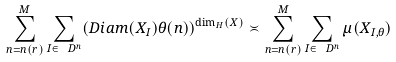Convert formula to latex. <formula><loc_0><loc_0><loc_500><loc_500>\sum _ { n = n ( r ) } ^ { M } \sum _ { I \in \ D ^ { n } } ( D i a m ( X _ { I } ) \theta ( n ) ) ^ { \dim _ { H } ( X ) } \asymp \sum _ { n = n ( r ) } ^ { M } \sum _ { I \in \ D ^ { n } } \mu ( X _ { I , \theta } )</formula> 